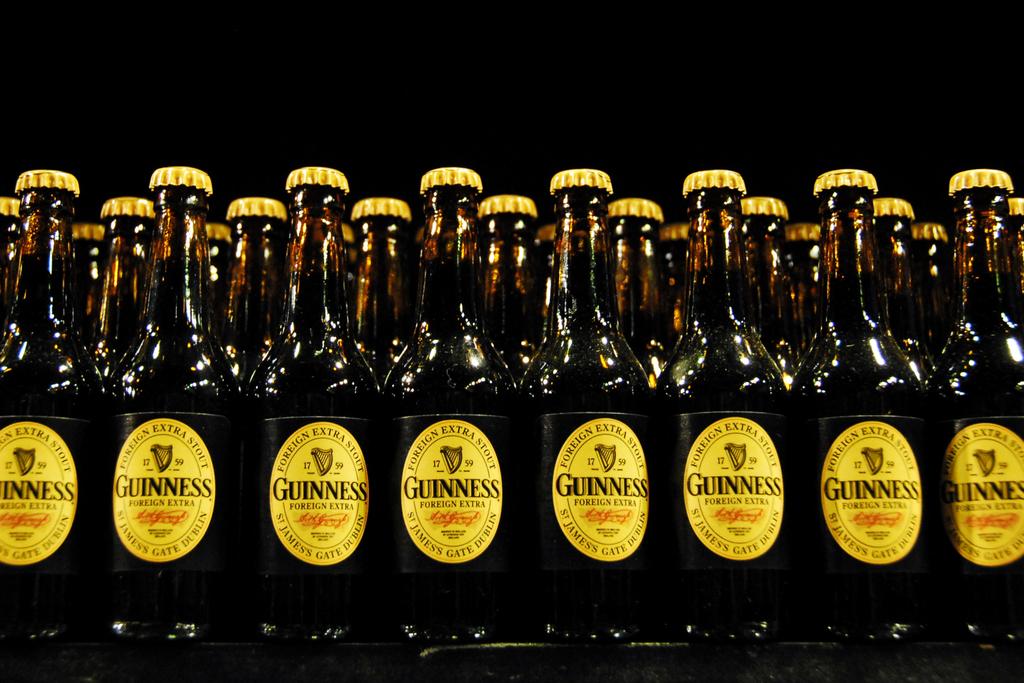What company makes guinness beer?
Provide a succinct answer. Guinness. 